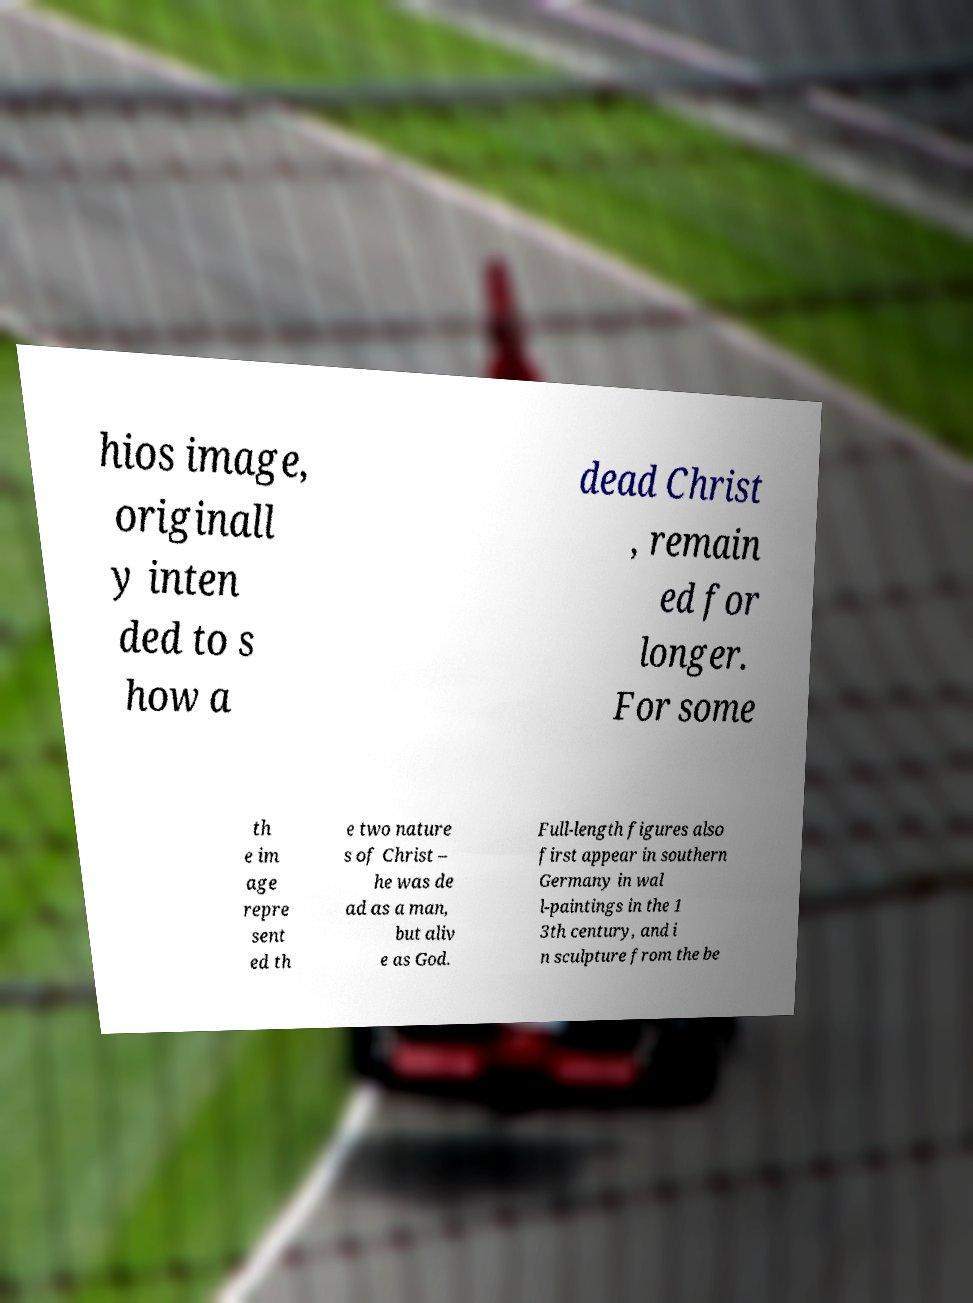Please identify and transcribe the text found in this image. hios image, originall y inten ded to s how a dead Christ , remain ed for longer. For some th e im age repre sent ed th e two nature s of Christ – he was de ad as a man, but aliv e as God. Full-length figures also first appear in southern Germany in wal l-paintings in the 1 3th century, and i n sculpture from the be 